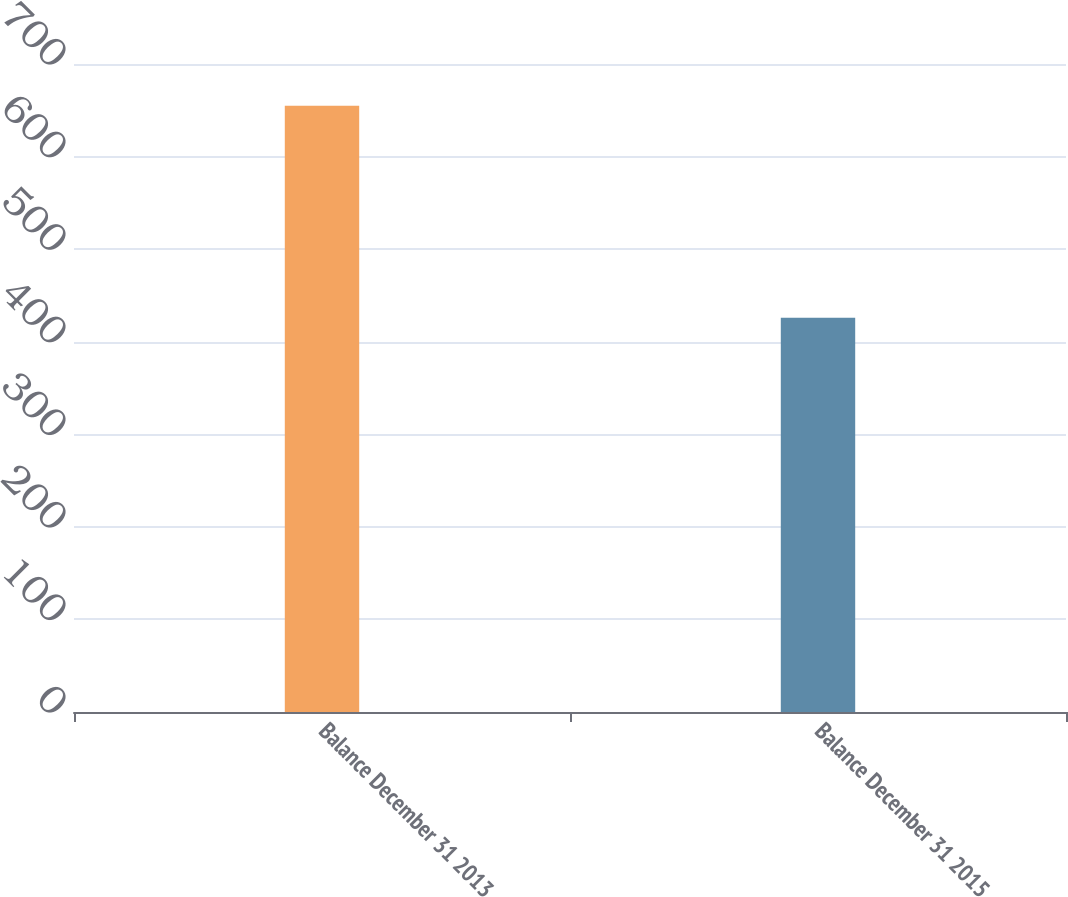Convert chart to OTSL. <chart><loc_0><loc_0><loc_500><loc_500><bar_chart><fcel>Balance December 31 2013<fcel>Balance December 31 2015<nl><fcel>655<fcel>426<nl></chart> 